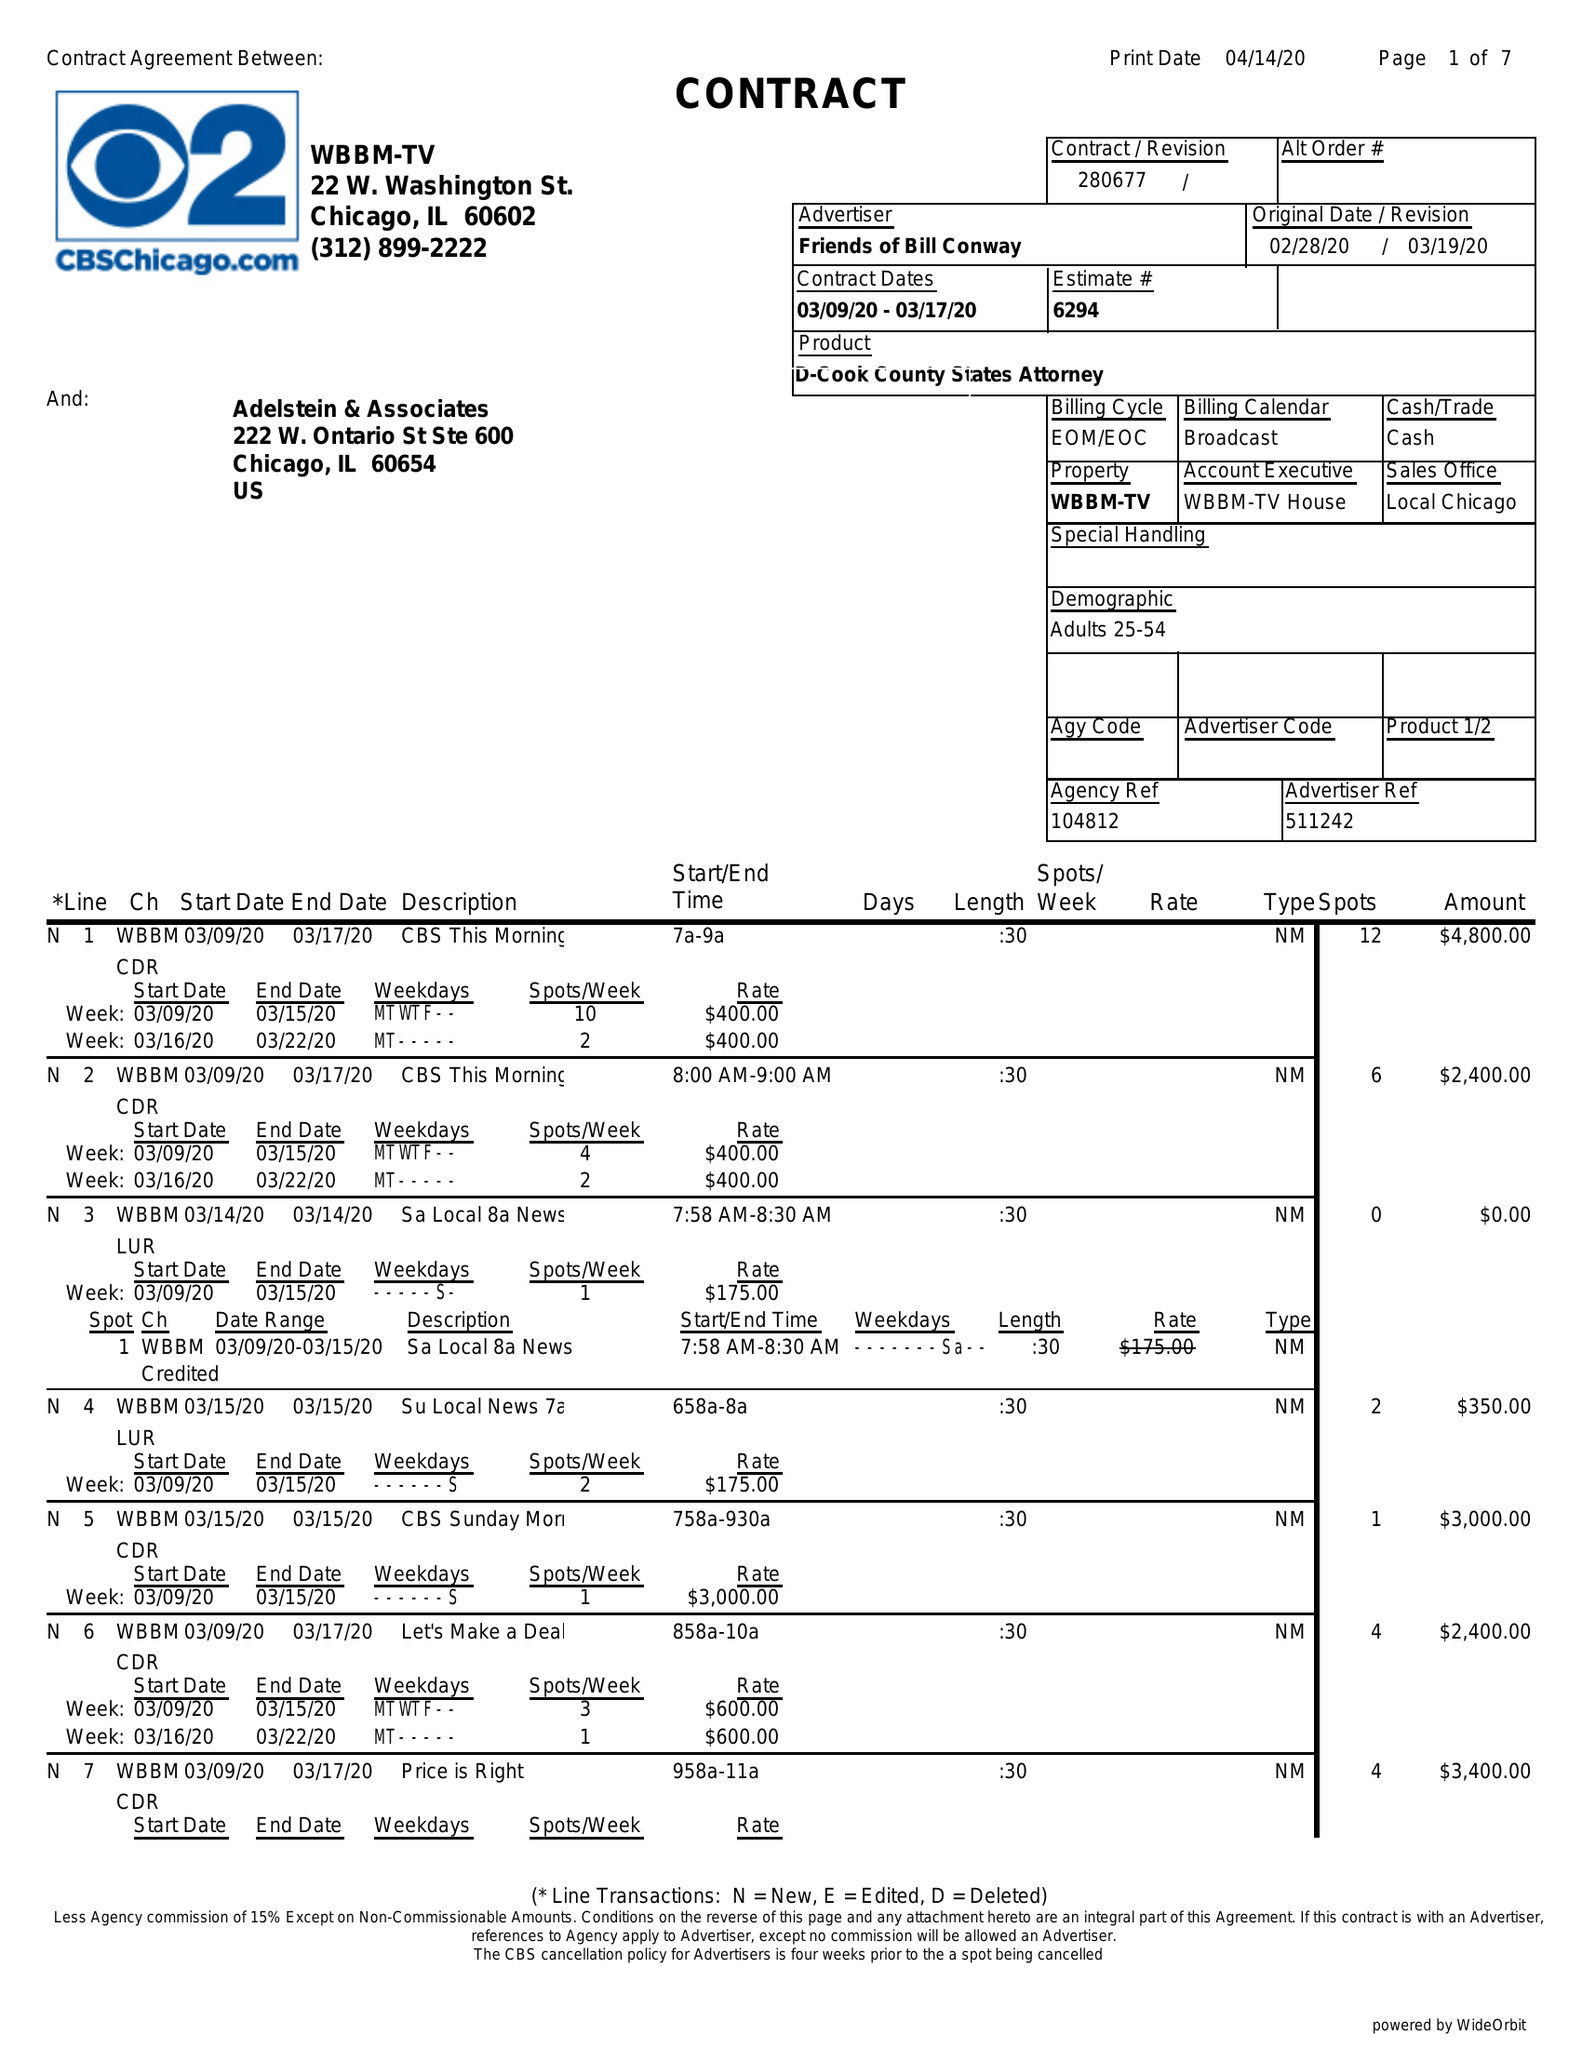What is the value for the gross_amount?
Answer the question using a single word or phrase. 133375.00 